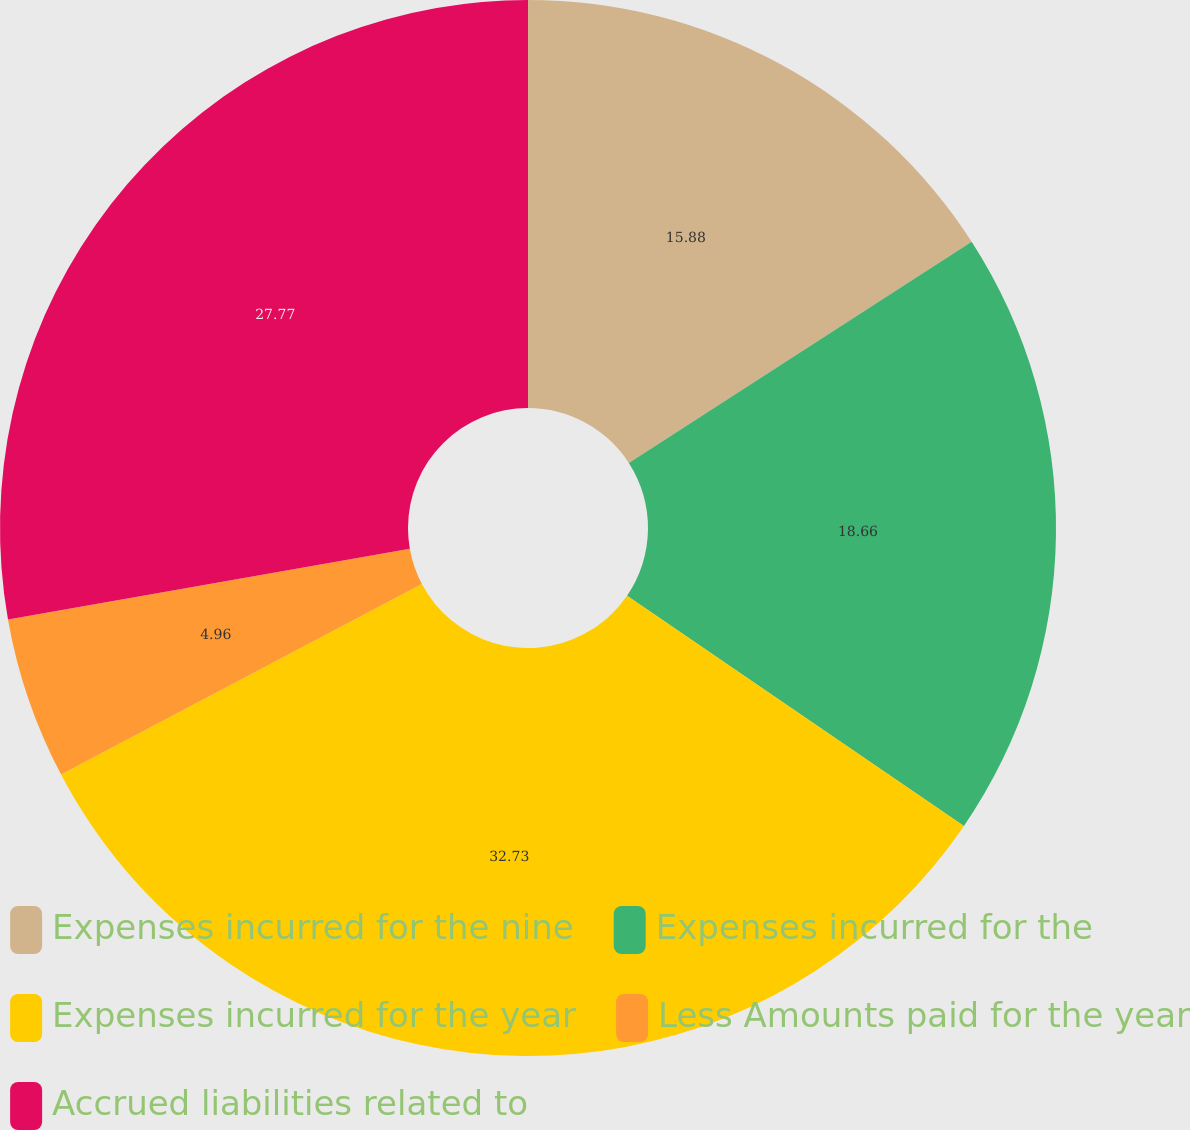Convert chart to OTSL. <chart><loc_0><loc_0><loc_500><loc_500><pie_chart><fcel>Expenses incurred for the nine<fcel>Expenses incurred for the<fcel>Expenses incurred for the year<fcel>Less Amounts paid for the year<fcel>Accrued liabilities related to<nl><fcel>15.88%<fcel>18.66%<fcel>32.73%<fcel>4.96%<fcel>27.77%<nl></chart> 